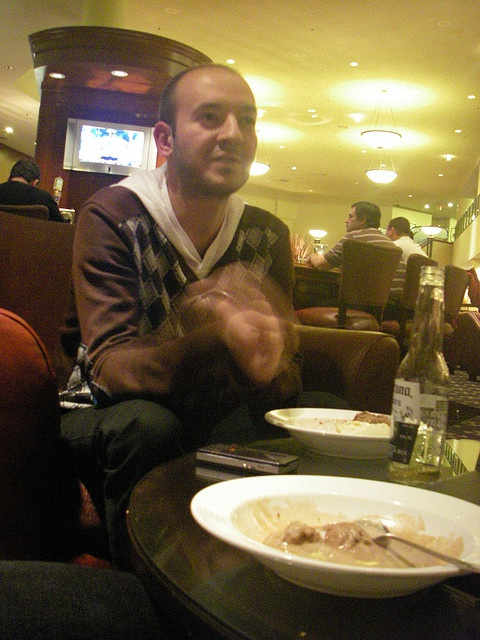Describe the objects in this image and their specific colors. I can see people in olive, black, maroon, and gray tones, dining table in olive, black, ivory, and khaki tones, bowl in olive, beige, khaki, and tan tones, chair in olive, black, maroon, and brown tones, and bottle in olive, tan, and black tones in this image. 